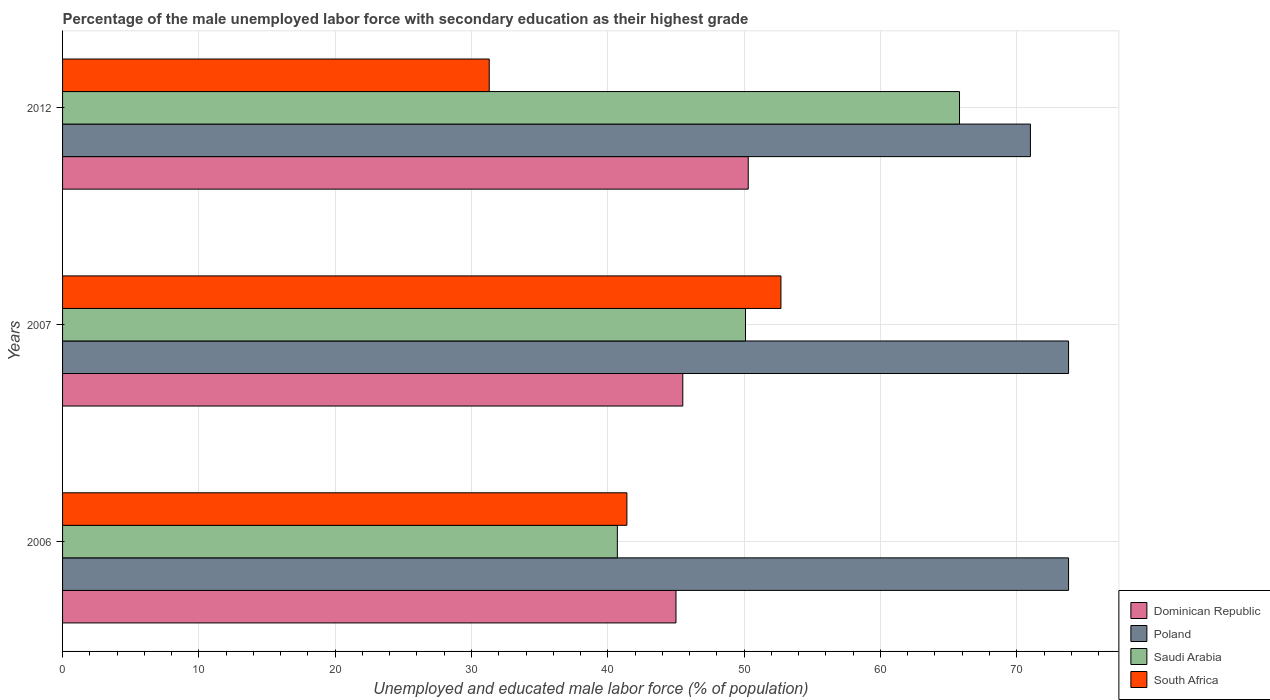Are the number of bars per tick equal to the number of legend labels?
Provide a succinct answer. Yes. Are the number of bars on each tick of the Y-axis equal?
Keep it short and to the point. Yes. In how many cases, is the number of bars for a given year not equal to the number of legend labels?
Provide a short and direct response. 0. What is the percentage of the unemployed male labor force with secondary education in Dominican Republic in 2006?
Your answer should be very brief. 45. Across all years, what is the maximum percentage of the unemployed male labor force with secondary education in South Africa?
Your answer should be compact. 52.7. Across all years, what is the minimum percentage of the unemployed male labor force with secondary education in South Africa?
Offer a very short reply. 31.3. In which year was the percentage of the unemployed male labor force with secondary education in Dominican Republic maximum?
Provide a succinct answer. 2012. What is the total percentage of the unemployed male labor force with secondary education in Saudi Arabia in the graph?
Your answer should be compact. 156.6. What is the difference between the percentage of the unemployed male labor force with secondary education in Saudi Arabia in 2007 and that in 2012?
Your response must be concise. -15.7. What is the difference between the percentage of the unemployed male labor force with secondary education in Saudi Arabia in 2007 and the percentage of the unemployed male labor force with secondary education in South Africa in 2012?
Your answer should be compact. 18.8. What is the average percentage of the unemployed male labor force with secondary education in Poland per year?
Ensure brevity in your answer.  72.87. In the year 2006, what is the difference between the percentage of the unemployed male labor force with secondary education in Poland and percentage of the unemployed male labor force with secondary education in South Africa?
Make the answer very short. 32.4. In how many years, is the percentage of the unemployed male labor force with secondary education in Dominican Republic greater than 40 %?
Your response must be concise. 3. What is the ratio of the percentage of the unemployed male labor force with secondary education in Poland in 2006 to that in 2012?
Your response must be concise. 1.04. Is the percentage of the unemployed male labor force with secondary education in Saudi Arabia in 2006 less than that in 2007?
Offer a very short reply. Yes. What is the difference between the highest and the second highest percentage of the unemployed male labor force with secondary education in Saudi Arabia?
Give a very brief answer. 15.7. What is the difference between the highest and the lowest percentage of the unemployed male labor force with secondary education in Saudi Arabia?
Give a very brief answer. 25.1. In how many years, is the percentage of the unemployed male labor force with secondary education in South Africa greater than the average percentage of the unemployed male labor force with secondary education in South Africa taken over all years?
Your answer should be very brief. 1. What does the 4th bar from the top in 2007 represents?
Offer a very short reply. Dominican Republic. What does the 1st bar from the bottom in 2007 represents?
Your response must be concise. Dominican Republic. Does the graph contain any zero values?
Provide a short and direct response. No. Does the graph contain grids?
Provide a short and direct response. Yes. How many legend labels are there?
Give a very brief answer. 4. How are the legend labels stacked?
Give a very brief answer. Vertical. What is the title of the graph?
Provide a succinct answer. Percentage of the male unemployed labor force with secondary education as their highest grade. What is the label or title of the X-axis?
Provide a short and direct response. Unemployed and educated male labor force (% of population). What is the label or title of the Y-axis?
Keep it short and to the point. Years. What is the Unemployed and educated male labor force (% of population) of Poland in 2006?
Your response must be concise. 73.8. What is the Unemployed and educated male labor force (% of population) of Saudi Arabia in 2006?
Give a very brief answer. 40.7. What is the Unemployed and educated male labor force (% of population) in South Africa in 2006?
Offer a very short reply. 41.4. What is the Unemployed and educated male labor force (% of population) in Dominican Republic in 2007?
Provide a short and direct response. 45.5. What is the Unemployed and educated male labor force (% of population) of Poland in 2007?
Provide a succinct answer. 73.8. What is the Unemployed and educated male labor force (% of population) of Saudi Arabia in 2007?
Offer a terse response. 50.1. What is the Unemployed and educated male labor force (% of population) in South Africa in 2007?
Offer a very short reply. 52.7. What is the Unemployed and educated male labor force (% of population) of Dominican Republic in 2012?
Your answer should be compact. 50.3. What is the Unemployed and educated male labor force (% of population) of Poland in 2012?
Offer a very short reply. 71. What is the Unemployed and educated male labor force (% of population) in Saudi Arabia in 2012?
Provide a succinct answer. 65.8. What is the Unemployed and educated male labor force (% of population) in South Africa in 2012?
Your answer should be very brief. 31.3. Across all years, what is the maximum Unemployed and educated male labor force (% of population) in Dominican Republic?
Ensure brevity in your answer.  50.3. Across all years, what is the maximum Unemployed and educated male labor force (% of population) of Poland?
Offer a terse response. 73.8. Across all years, what is the maximum Unemployed and educated male labor force (% of population) of Saudi Arabia?
Give a very brief answer. 65.8. Across all years, what is the maximum Unemployed and educated male labor force (% of population) in South Africa?
Your response must be concise. 52.7. Across all years, what is the minimum Unemployed and educated male labor force (% of population) of Dominican Republic?
Offer a very short reply. 45. Across all years, what is the minimum Unemployed and educated male labor force (% of population) of Poland?
Give a very brief answer. 71. Across all years, what is the minimum Unemployed and educated male labor force (% of population) in Saudi Arabia?
Keep it short and to the point. 40.7. Across all years, what is the minimum Unemployed and educated male labor force (% of population) in South Africa?
Provide a short and direct response. 31.3. What is the total Unemployed and educated male labor force (% of population) of Dominican Republic in the graph?
Your answer should be very brief. 140.8. What is the total Unemployed and educated male labor force (% of population) of Poland in the graph?
Offer a very short reply. 218.6. What is the total Unemployed and educated male labor force (% of population) of Saudi Arabia in the graph?
Give a very brief answer. 156.6. What is the total Unemployed and educated male labor force (% of population) of South Africa in the graph?
Your response must be concise. 125.4. What is the difference between the Unemployed and educated male labor force (% of population) in Dominican Republic in 2006 and that in 2012?
Offer a very short reply. -5.3. What is the difference between the Unemployed and educated male labor force (% of population) of Poland in 2006 and that in 2012?
Make the answer very short. 2.8. What is the difference between the Unemployed and educated male labor force (% of population) of Saudi Arabia in 2006 and that in 2012?
Offer a very short reply. -25.1. What is the difference between the Unemployed and educated male labor force (% of population) in Saudi Arabia in 2007 and that in 2012?
Ensure brevity in your answer.  -15.7. What is the difference between the Unemployed and educated male labor force (% of population) in South Africa in 2007 and that in 2012?
Your answer should be compact. 21.4. What is the difference between the Unemployed and educated male labor force (% of population) in Dominican Republic in 2006 and the Unemployed and educated male labor force (% of population) in Poland in 2007?
Offer a very short reply. -28.8. What is the difference between the Unemployed and educated male labor force (% of population) of Poland in 2006 and the Unemployed and educated male labor force (% of population) of Saudi Arabia in 2007?
Make the answer very short. 23.7. What is the difference between the Unemployed and educated male labor force (% of population) of Poland in 2006 and the Unemployed and educated male labor force (% of population) of South Africa in 2007?
Provide a short and direct response. 21.1. What is the difference between the Unemployed and educated male labor force (% of population) of Dominican Republic in 2006 and the Unemployed and educated male labor force (% of population) of Poland in 2012?
Provide a succinct answer. -26. What is the difference between the Unemployed and educated male labor force (% of population) in Dominican Republic in 2006 and the Unemployed and educated male labor force (% of population) in Saudi Arabia in 2012?
Offer a very short reply. -20.8. What is the difference between the Unemployed and educated male labor force (% of population) of Dominican Republic in 2006 and the Unemployed and educated male labor force (% of population) of South Africa in 2012?
Your answer should be compact. 13.7. What is the difference between the Unemployed and educated male labor force (% of population) in Poland in 2006 and the Unemployed and educated male labor force (% of population) in South Africa in 2012?
Your answer should be compact. 42.5. What is the difference between the Unemployed and educated male labor force (% of population) in Saudi Arabia in 2006 and the Unemployed and educated male labor force (% of population) in South Africa in 2012?
Ensure brevity in your answer.  9.4. What is the difference between the Unemployed and educated male labor force (% of population) in Dominican Republic in 2007 and the Unemployed and educated male labor force (% of population) in Poland in 2012?
Offer a very short reply. -25.5. What is the difference between the Unemployed and educated male labor force (% of population) of Dominican Republic in 2007 and the Unemployed and educated male labor force (% of population) of Saudi Arabia in 2012?
Provide a short and direct response. -20.3. What is the difference between the Unemployed and educated male labor force (% of population) in Poland in 2007 and the Unemployed and educated male labor force (% of population) in Saudi Arabia in 2012?
Your answer should be very brief. 8. What is the difference between the Unemployed and educated male labor force (% of population) in Poland in 2007 and the Unemployed and educated male labor force (% of population) in South Africa in 2012?
Keep it short and to the point. 42.5. What is the average Unemployed and educated male labor force (% of population) in Dominican Republic per year?
Make the answer very short. 46.93. What is the average Unemployed and educated male labor force (% of population) in Poland per year?
Ensure brevity in your answer.  72.87. What is the average Unemployed and educated male labor force (% of population) of Saudi Arabia per year?
Provide a succinct answer. 52.2. What is the average Unemployed and educated male labor force (% of population) in South Africa per year?
Your answer should be compact. 41.8. In the year 2006, what is the difference between the Unemployed and educated male labor force (% of population) of Dominican Republic and Unemployed and educated male labor force (% of population) of Poland?
Your answer should be very brief. -28.8. In the year 2006, what is the difference between the Unemployed and educated male labor force (% of population) of Poland and Unemployed and educated male labor force (% of population) of Saudi Arabia?
Ensure brevity in your answer.  33.1. In the year 2006, what is the difference between the Unemployed and educated male labor force (% of population) in Poland and Unemployed and educated male labor force (% of population) in South Africa?
Offer a terse response. 32.4. In the year 2007, what is the difference between the Unemployed and educated male labor force (% of population) of Dominican Republic and Unemployed and educated male labor force (% of population) of Poland?
Your answer should be compact. -28.3. In the year 2007, what is the difference between the Unemployed and educated male labor force (% of population) in Dominican Republic and Unemployed and educated male labor force (% of population) in Saudi Arabia?
Provide a succinct answer. -4.6. In the year 2007, what is the difference between the Unemployed and educated male labor force (% of population) of Poland and Unemployed and educated male labor force (% of population) of Saudi Arabia?
Your answer should be very brief. 23.7. In the year 2007, what is the difference between the Unemployed and educated male labor force (% of population) of Poland and Unemployed and educated male labor force (% of population) of South Africa?
Provide a short and direct response. 21.1. In the year 2012, what is the difference between the Unemployed and educated male labor force (% of population) of Dominican Republic and Unemployed and educated male labor force (% of population) of Poland?
Offer a very short reply. -20.7. In the year 2012, what is the difference between the Unemployed and educated male labor force (% of population) in Dominican Republic and Unemployed and educated male labor force (% of population) in Saudi Arabia?
Make the answer very short. -15.5. In the year 2012, what is the difference between the Unemployed and educated male labor force (% of population) of Dominican Republic and Unemployed and educated male labor force (% of population) of South Africa?
Provide a short and direct response. 19. In the year 2012, what is the difference between the Unemployed and educated male labor force (% of population) of Poland and Unemployed and educated male labor force (% of population) of South Africa?
Your response must be concise. 39.7. In the year 2012, what is the difference between the Unemployed and educated male labor force (% of population) in Saudi Arabia and Unemployed and educated male labor force (% of population) in South Africa?
Make the answer very short. 34.5. What is the ratio of the Unemployed and educated male labor force (% of population) in Poland in 2006 to that in 2007?
Provide a succinct answer. 1. What is the ratio of the Unemployed and educated male labor force (% of population) of Saudi Arabia in 2006 to that in 2007?
Your response must be concise. 0.81. What is the ratio of the Unemployed and educated male labor force (% of population) of South Africa in 2006 to that in 2007?
Provide a succinct answer. 0.79. What is the ratio of the Unemployed and educated male labor force (% of population) of Dominican Republic in 2006 to that in 2012?
Make the answer very short. 0.89. What is the ratio of the Unemployed and educated male labor force (% of population) of Poland in 2006 to that in 2012?
Give a very brief answer. 1.04. What is the ratio of the Unemployed and educated male labor force (% of population) of Saudi Arabia in 2006 to that in 2012?
Keep it short and to the point. 0.62. What is the ratio of the Unemployed and educated male labor force (% of population) of South Africa in 2006 to that in 2012?
Ensure brevity in your answer.  1.32. What is the ratio of the Unemployed and educated male labor force (% of population) in Dominican Republic in 2007 to that in 2012?
Keep it short and to the point. 0.9. What is the ratio of the Unemployed and educated male labor force (% of population) in Poland in 2007 to that in 2012?
Provide a succinct answer. 1.04. What is the ratio of the Unemployed and educated male labor force (% of population) in Saudi Arabia in 2007 to that in 2012?
Offer a terse response. 0.76. What is the ratio of the Unemployed and educated male labor force (% of population) of South Africa in 2007 to that in 2012?
Provide a short and direct response. 1.68. What is the difference between the highest and the second highest Unemployed and educated male labor force (% of population) in Dominican Republic?
Offer a very short reply. 4.8. What is the difference between the highest and the second highest Unemployed and educated male labor force (% of population) of Saudi Arabia?
Ensure brevity in your answer.  15.7. What is the difference between the highest and the second highest Unemployed and educated male labor force (% of population) in South Africa?
Ensure brevity in your answer.  11.3. What is the difference between the highest and the lowest Unemployed and educated male labor force (% of population) in Poland?
Keep it short and to the point. 2.8. What is the difference between the highest and the lowest Unemployed and educated male labor force (% of population) of Saudi Arabia?
Provide a short and direct response. 25.1. What is the difference between the highest and the lowest Unemployed and educated male labor force (% of population) in South Africa?
Give a very brief answer. 21.4. 